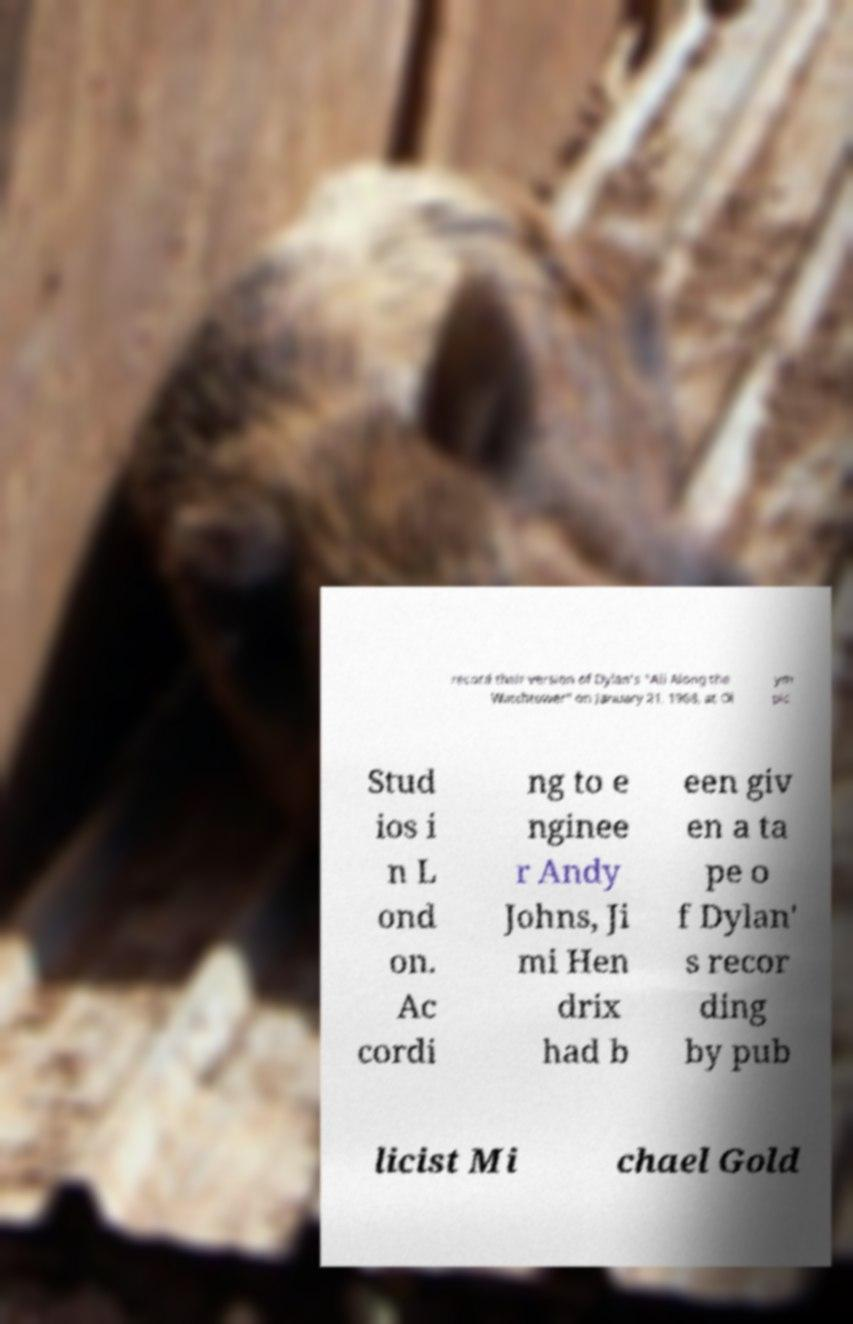Can you read and provide the text displayed in the image?This photo seems to have some interesting text. Can you extract and type it out for me? record their version of Dylan's "All Along the Watchtower" on January 21, 1968, at Ol ym pic Stud ios i n L ond on. Ac cordi ng to e nginee r Andy Johns, Ji mi Hen drix had b een giv en a ta pe o f Dylan' s recor ding by pub licist Mi chael Gold 